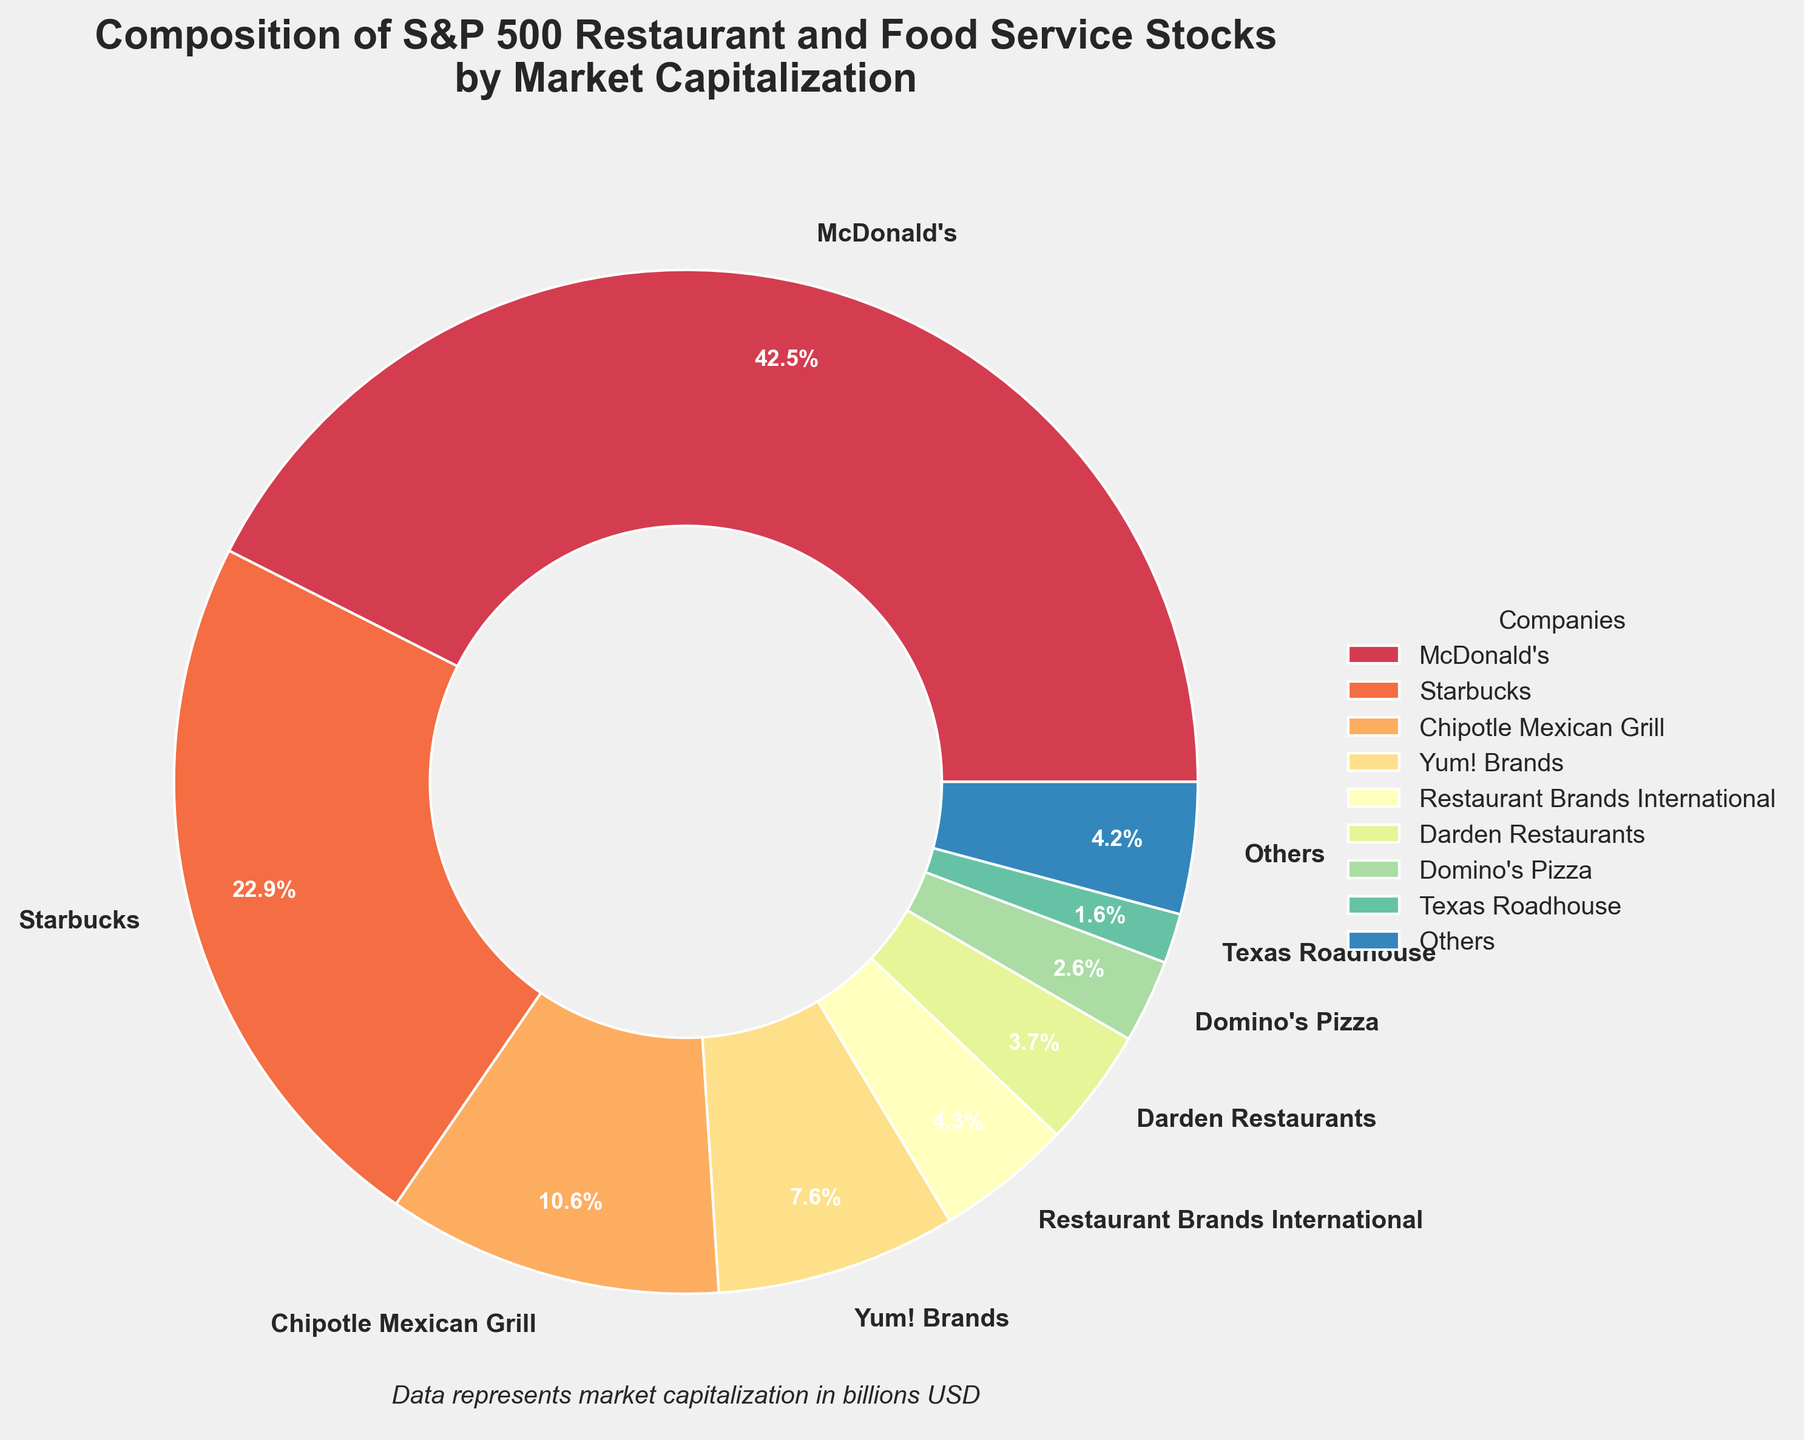What percentage of the market capitalization does McDonald's hold? McDonald's slice of the pie chart would show its percentage share. This percentage is 213.5 billion USD divided by the total of all market caps and multiplied by 100.
Answer: 52.4% How much larger is McDonald's market cap compared to Starbucks? Subtract Starbucks' market cap from McDonald's market cap (213.5 - 114.8 = 98.7 billion USD).
Answer: 98.7 billion USD What is the combined market capitalization of Chipotle Mexican Grill and Yum! Brands? Add the market caps of Chipotle Mexican Grill and Yum! Brands (53.2 + 38.1 = 91.3 billion USD).
Answer: 91.3 billion USD Which company has the smallest market share, and what is its percentage? The smallest wedge in the pie belongs to Jack in the Box with a market cap of 1.8 billion USD. The percentage is 1.8 billion divided by the total market cap, then multiplied by 100.
Answer: Jack in the Box, 0.4% What are the combined percentages of the companies labeled as "Others"? Sum the percentages of the companies grouped under "Others". This information is represented in one are of the pie chart.
Answer: 9.4% How does the market capitalization of Texas Roadhouse compare to that of Wingstop? Subtract Wingstop's market cap from Texas Roadhouse's market cap (7.9 - 5.6 = 2.3 billion USD).
Answer: 2.3 billion USD Which companies are represented by colors in the spectral palette closer to white? Look at the pie chart and see which slices are lighter in color. By process of elimination based on the known market caps, the labels suggest that companies with a smaller slice, such as Shake Shack and Papa John's, tend to be lighter.
Answer: Shake Shack, Papa John's What is the difference in market cap percentage between Darden Restaurants and Restaurant Brands International? Subtract Restaurant Brands International's percentage from Darden Restaurants' percentage (18.7 - 21.5 = -2.8 billion), calculate percentages (5.7% - 6.6% = -0.9%).
Answer: -0.9% How does the cumulative market capitalization of the top 4 companies compare to the rest? Add the market caps of the top 4 companies (McDonald's, Starbucks, Chipotle Mexican Grill, and Yum! Brands), then compare to the total market cap minus the top 4 companies' market cap.
Answer: Top 4: $419.6 Billion, Rest: $69.4 Billion What colors represent McDonald's and Starbucks on the pie chart? Look at the pie chart to see which colors correspond to the large slices labeled as McDonald's and Starbucks. These colors are likely the first two in the spectral palette.
Answer: McDonald's: Purple, Starbucks: Red 